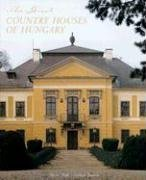Could you recommend any other similar books that explore Hungarian architecture or history? If you're intrigued by the breathtaking architecture of Hungary, you might also enjoy titles like 'Budapest 1900: A Historical Portrait of a City and Its Culture' or 'Hungary's Heritage: Princely Estates and Aristocratic Residences.' These books delve into the architectural wonders and historical narratives of Hungary's past. 